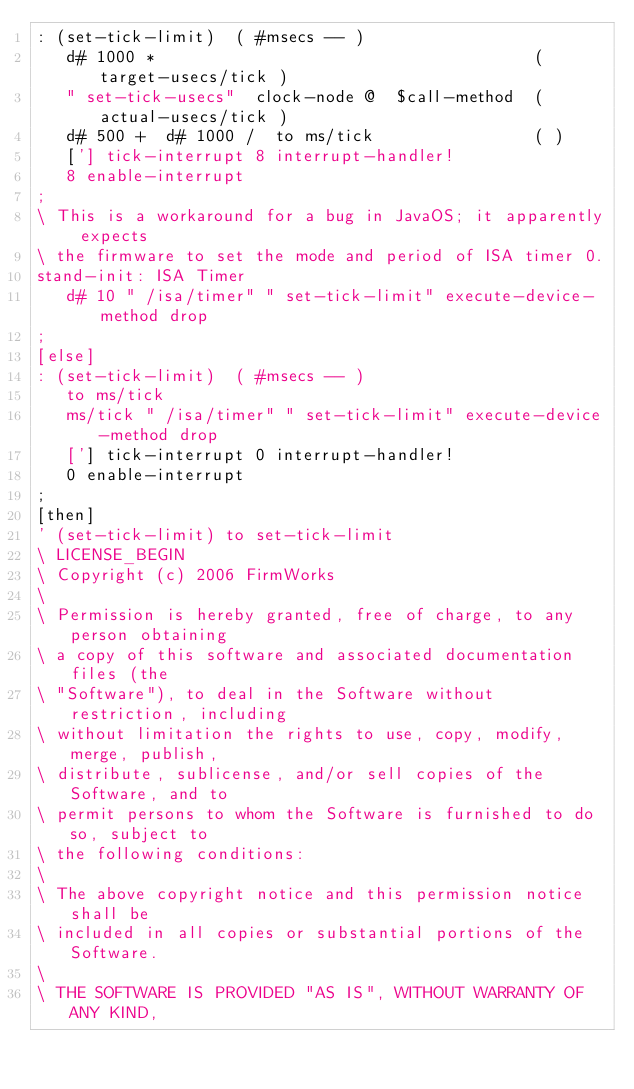<code> <loc_0><loc_0><loc_500><loc_500><_Forth_>: (set-tick-limit)  ( #msecs -- )
   d# 1000 *                                      ( target-usecs/tick )
   " set-tick-usecs"  clock-node @  $call-method  ( actual-usecs/tick )
   d# 500 +  d# 1000 /  to ms/tick                ( )
   ['] tick-interrupt 8 interrupt-handler!
   8 enable-interrupt
;
\ This is a workaround for a bug in JavaOS; it apparently expects
\ the firmware to set the mode and period of ISA timer 0.
stand-init: ISA Timer
   d# 10 " /isa/timer" " set-tick-limit" execute-device-method drop
;
[else]
: (set-tick-limit)  ( #msecs -- )
   to ms/tick
   ms/tick " /isa/timer" " set-tick-limit" execute-device-method drop
   ['] tick-interrupt 0 interrupt-handler!
   0 enable-interrupt
;
[then]
' (set-tick-limit) to set-tick-limit
\ LICENSE_BEGIN
\ Copyright (c) 2006 FirmWorks
\ 
\ Permission is hereby granted, free of charge, to any person obtaining
\ a copy of this software and associated documentation files (the
\ "Software"), to deal in the Software without restriction, including
\ without limitation the rights to use, copy, modify, merge, publish,
\ distribute, sublicense, and/or sell copies of the Software, and to
\ permit persons to whom the Software is furnished to do so, subject to
\ the following conditions:
\ 
\ The above copyright notice and this permission notice shall be
\ included in all copies or substantial portions of the Software.
\ 
\ THE SOFTWARE IS PROVIDED "AS IS", WITHOUT WARRANTY OF ANY KIND,</code> 